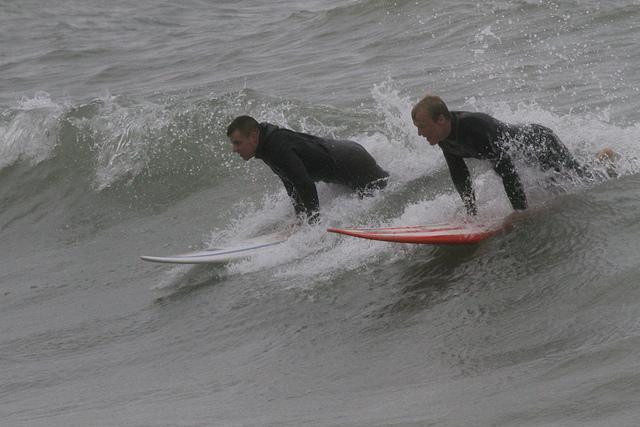How many people are surfing?
Give a very brief answer. 2. How many people can you see?
Give a very brief answer. 2. How many cats are meowing on a bed?
Give a very brief answer. 0. 